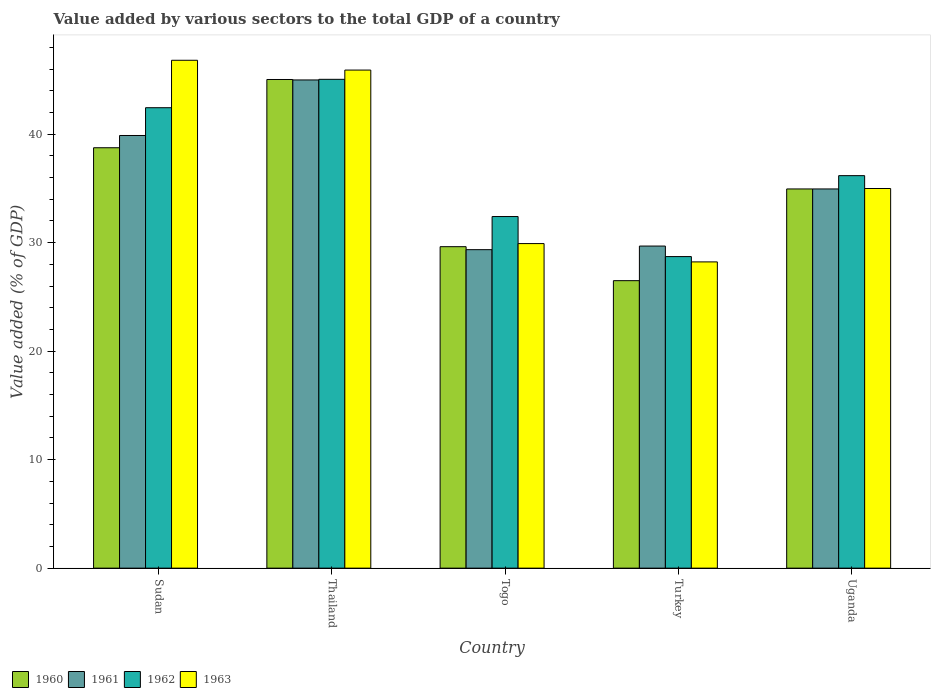How many different coloured bars are there?
Provide a succinct answer. 4. How many groups of bars are there?
Give a very brief answer. 5. Are the number of bars per tick equal to the number of legend labels?
Your answer should be compact. Yes. What is the label of the 2nd group of bars from the left?
Your response must be concise. Thailand. What is the value added by various sectors to the total GDP in 1961 in Togo?
Your answer should be compact. 29.35. Across all countries, what is the maximum value added by various sectors to the total GDP in 1960?
Ensure brevity in your answer.  45.04. Across all countries, what is the minimum value added by various sectors to the total GDP in 1962?
Your response must be concise. 28.72. In which country was the value added by various sectors to the total GDP in 1960 maximum?
Offer a terse response. Thailand. In which country was the value added by various sectors to the total GDP in 1962 minimum?
Make the answer very short. Turkey. What is the total value added by various sectors to the total GDP in 1961 in the graph?
Your response must be concise. 178.87. What is the difference between the value added by various sectors to the total GDP in 1963 in Sudan and that in Uganda?
Offer a very short reply. 11.82. What is the difference between the value added by various sectors to the total GDP in 1961 in Sudan and the value added by various sectors to the total GDP in 1960 in Turkey?
Your response must be concise. 13.38. What is the average value added by various sectors to the total GDP in 1962 per country?
Your response must be concise. 36.96. What is the difference between the value added by various sectors to the total GDP of/in 1962 and value added by various sectors to the total GDP of/in 1961 in Turkey?
Offer a terse response. -0.97. In how many countries, is the value added by various sectors to the total GDP in 1962 greater than 24 %?
Provide a succinct answer. 5. What is the ratio of the value added by various sectors to the total GDP in 1962 in Sudan to that in Thailand?
Provide a succinct answer. 0.94. What is the difference between the highest and the second highest value added by various sectors to the total GDP in 1961?
Your answer should be very brief. -10.05. What is the difference between the highest and the lowest value added by various sectors to the total GDP in 1963?
Provide a succinct answer. 18.58. Is the sum of the value added by various sectors to the total GDP in 1962 in Thailand and Uganda greater than the maximum value added by various sectors to the total GDP in 1961 across all countries?
Give a very brief answer. Yes. What does the 2nd bar from the left in Sudan represents?
Offer a very short reply. 1961. Is it the case that in every country, the sum of the value added by various sectors to the total GDP in 1960 and value added by various sectors to the total GDP in 1962 is greater than the value added by various sectors to the total GDP in 1961?
Keep it short and to the point. Yes. How many countries are there in the graph?
Your answer should be compact. 5. Are the values on the major ticks of Y-axis written in scientific E-notation?
Keep it short and to the point. No. How many legend labels are there?
Make the answer very short. 4. How are the legend labels stacked?
Provide a short and direct response. Horizontal. What is the title of the graph?
Make the answer very short. Value added by various sectors to the total GDP of a country. Does "2004" appear as one of the legend labels in the graph?
Your answer should be very brief. No. What is the label or title of the X-axis?
Offer a terse response. Country. What is the label or title of the Y-axis?
Provide a succinct answer. Value added (% of GDP). What is the Value added (% of GDP) of 1960 in Sudan?
Provide a short and direct response. 38.75. What is the Value added (% of GDP) in 1961 in Sudan?
Your answer should be compact. 39.88. What is the Value added (% of GDP) in 1962 in Sudan?
Keep it short and to the point. 42.44. What is the Value added (% of GDP) of 1963 in Sudan?
Your response must be concise. 46.81. What is the Value added (% of GDP) in 1960 in Thailand?
Provide a short and direct response. 45.04. What is the Value added (% of GDP) of 1961 in Thailand?
Keep it short and to the point. 45. What is the Value added (% of GDP) in 1962 in Thailand?
Your answer should be very brief. 45.05. What is the Value added (% of GDP) of 1963 in Thailand?
Make the answer very short. 45.91. What is the Value added (% of GDP) in 1960 in Togo?
Provide a short and direct response. 29.63. What is the Value added (% of GDP) of 1961 in Togo?
Give a very brief answer. 29.35. What is the Value added (% of GDP) of 1962 in Togo?
Offer a very short reply. 32.41. What is the Value added (% of GDP) of 1963 in Togo?
Provide a succinct answer. 29.91. What is the Value added (% of GDP) in 1960 in Turkey?
Provide a short and direct response. 26.5. What is the Value added (% of GDP) in 1961 in Turkey?
Provide a short and direct response. 29.69. What is the Value added (% of GDP) of 1962 in Turkey?
Your answer should be very brief. 28.72. What is the Value added (% of GDP) of 1963 in Turkey?
Provide a succinct answer. 28.23. What is the Value added (% of GDP) in 1960 in Uganda?
Give a very brief answer. 34.95. What is the Value added (% of GDP) of 1961 in Uganda?
Offer a terse response. 34.95. What is the Value added (% of GDP) of 1962 in Uganda?
Your response must be concise. 36.18. What is the Value added (% of GDP) in 1963 in Uganda?
Offer a terse response. 34.99. Across all countries, what is the maximum Value added (% of GDP) of 1960?
Your answer should be compact. 45.04. Across all countries, what is the maximum Value added (% of GDP) of 1961?
Your response must be concise. 45. Across all countries, what is the maximum Value added (% of GDP) of 1962?
Keep it short and to the point. 45.05. Across all countries, what is the maximum Value added (% of GDP) of 1963?
Offer a terse response. 46.81. Across all countries, what is the minimum Value added (% of GDP) in 1960?
Your response must be concise. 26.5. Across all countries, what is the minimum Value added (% of GDP) in 1961?
Provide a short and direct response. 29.35. Across all countries, what is the minimum Value added (% of GDP) in 1962?
Make the answer very short. 28.72. Across all countries, what is the minimum Value added (% of GDP) in 1963?
Offer a very short reply. 28.23. What is the total Value added (% of GDP) of 1960 in the graph?
Your answer should be very brief. 174.87. What is the total Value added (% of GDP) of 1961 in the graph?
Ensure brevity in your answer.  178.87. What is the total Value added (% of GDP) in 1962 in the graph?
Offer a terse response. 184.79. What is the total Value added (% of GDP) in 1963 in the graph?
Your response must be concise. 185.85. What is the difference between the Value added (% of GDP) of 1960 in Sudan and that in Thailand?
Provide a succinct answer. -6.29. What is the difference between the Value added (% of GDP) in 1961 in Sudan and that in Thailand?
Offer a very short reply. -5.12. What is the difference between the Value added (% of GDP) of 1962 in Sudan and that in Thailand?
Your answer should be compact. -2.62. What is the difference between the Value added (% of GDP) of 1963 in Sudan and that in Thailand?
Keep it short and to the point. 0.9. What is the difference between the Value added (% of GDP) in 1960 in Sudan and that in Togo?
Offer a terse response. 9.12. What is the difference between the Value added (% of GDP) of 1961 in Sudan and that in Togo?
Offer a very short reply. 10.52. What is the difference between the Value added (% of GDP) in 1962 in Sudan and that in Togo?
Offer a terse response. 10.03. What is the difference between the Value added (% of GDP) in 1963 in Sudan and that in Togo?
Keep it short and to the point. 16.9. What is the difference between the Value added (% of GDP) of 1960 in Sudan and that in Turkey?
Offer a terse response. 12.25. What is the difference between the Value added (% of GDP) in 1961 in Sudan and that in Turkey?
Offer a very short reply. 10.19. What is the difference between the Value added (% of GDP) of 1962 in Sudan and that in Turkey?
Your response must be concise. 13.72. What is the difference between the Value added (% of GDP) of 1963 in Sudan and that in Turkey?
Offer a terse response. 18.58. What is the difference between the Value added (% of GDP) of 1960 in Sudan and that in Uganda?
Ensure brevity in your answer.  3.8. What is the difference between the Value added (% of GDP) in 1961 in Sudan and that in Uganda?
Offer a terse response. 4.93. What is the difference between the Value added (% of GDP) in 1962 in Sudan and that in Uganda?
Your answer should be compact. 6.26. What is the difference between the Value added (% of GDP) in 1963 in Sudan and that in Uganda?
Provide a succinct answer. 11.82. What is the difference between the Value added (% of GDP) in 1960 in Thailand and that in Togo?
Give a very brief answer. 15.41. What is the difference between the Value added (% of GDP) in 1961 in Thailand and that in Togo?
Your response must be concise. 15.64. What is the difference between the Value added (% of GDP) in 1962 in Thailand and that in Togo?
Your answer should be compact. 12.65. What is the difference between the Value added (% of GDP) in 1963 in Thailand and that in Togo?
Give a very brief answer. 15.99. What is the difference between the Value added (% of GDP) in 1960 in Thailand and that in Turkey?
Provide a succinct answer. 18.54. What is the difference between the Value added (% of GDP) of 1961 in Thailand and that in Turkey?
Provide a succinct answer. 15.31. What is the difference between the Value added (% of GDP) in 1962 in Thailand and that in Turkey?
Offer a terse response. 16.34. What is the difference between the Value added (% of GDP) of 1963 in Thailand and that in Turkey?
Make the answer very short. 17.68. What is the difference between the Value added (% of GDP) of 1960 in Thailand and that in Uganda?
Ensure brevity in your answer.  10.09. What is the difference between the Value added (% of GDP) of 1961 in Thailand and that in Uganda?
Your response must be concise. 10.05. What is the difference between the Value added (% of GDP) in 1962 in Thailand and that in Uganda?
Your answer should be very brief. 8.88. What is the difference between the Value added (% of GDP) of 1963 in Thailand and that in Uganda?
Your response must be concise. 10.92. What is the difference between the Value added (% of GDP) of 1960 in Togo and that in Turkey?
Offer a very short reply. 3.13. What is the difference between the Value added (% of GDP) of 1961 in Togo and that in Turkey?
Your answer should be very brief. -0.33. What is the difference between the Value added (% of GDP) in 1962 in Togo and that in Turkey?
Your answer should be very brief. 3.69. What is the difference between the Value added (% of GDP) of 1963 in Togo and that in Turkey?
Your answer should be compact. 1.69. What is the difference between the Value added (% of GDP) in 1960 in Togo and that in Uganda?
Keep it short and to the point. -5.32. What is the difference between the Value added (% of GDP) in 1961 in Togo and that in Uganda?
Your response must be concise. -5.6. What is the difference between the Value added (% of GDP) in 1962 in Togo and that in Uganda?
Make the answer very short. -3.77. What is the difference between the Value added (% of GDP) in 1963 in Togo and that in Uganda?
Offer a terse response. -5.08. What is the difference between the Value added (% of GDP) in 1960 in Turkey and that in Uganda?
Make the answer very short. -8.45. What is the difference between the Value added (% of GDP) in 1961 in Turkey and that in Uganda?
Offer a very short reply. -5.26. What is the difference between the Value added (% of GDP) of 1962 in Turkey and that in Uganda?
Offer a terse response. -7.46. What is the difference between the Value added (% of GDP) of 1963 in Turkey and that in Uganda?
Provide a short and direct response. -6.76. What is the difference between the Value added (% of GDP) of 1960 in Sudan and the Value added (% of GDP) of 1961 in Thailand?
Your answer should be very brief. -6.25. What is the difference between the Value added (% of GDP) in 1960 in Sudan and the Value added (% of GDP) in 1962 in Thailand?
Give a very brief answer. -6.31. What is the difference between the Value added (% of GDP) in 1960 in Sudan and the Value added (% of GDP) in 1963 in Thailand?
Keep it short and to the point. -7.16. What is the difference between the Value added (% of GDP) in 1961 in Sudan and the Value added (% of GDP) in 1962 in Thailand?
Provide a short and direct response. -5.18. What is the difference between the Value added (% of GDP) in 1961 in Sudan and the Value added (% of GDP) in 1963 in Thailand?
Provide a short and direct response. -6.03. What is the difference between the Value added (% of GDP) in 1962 in Sudan and the Value added (% of GDP) in 1963 in Thailand?
Your answer should be very brief. -3.47. What is the difference between the Value added (% of GDP) in 1960 in Sudan and the Value added (% of GDP) in 1961 in Togo?
Offer a terse response. 9.39. What is the difference between the Value added (% of GDP) of 1960 in Sudan and the Value added (% of GDP) of 1962 in Togo?
Provide a succinct answer. 6.34. What is the difference between the Value added (% of GDP) of 1960 in Sudan and the Value added (% of GDP) of 1963 in Togo?
Provide a short and direct response. 8.83. What is the difference between the Value added (% of GDP) in 1961 in Sudan and the Value added (% of GDP) in 1962 in Togo?
Your answer should be compact. 7.47. What is the difference between the Value added (% of GDP) of 1961 in Sudan and the Value added (% of GDP) of 1963 in Togo?
Your response must be concise. 9.96. What is the difference between the Value added (% of GDP) of 1962 in Sudan and the Value added (% of GDP) of 1963 in Togo?
Your answer should be very brief. 12.52. What is the difference between the Value added (% of GDP) of 1960 in Sudan and the Value added (% of GDP) of 1961 in Turkey?
Provide a succinct answer. 9.06. What is the difference between the Value added (% of GDP) in 1960 in Sudan and the Value added (% of GDP) in 1962 in Turkey?
Provide a succinct answer. 10.03. What is the difference between the Value added (% of GDP) of 1960 in Sudan and the Value added (% of GDP) of 1963 in Turkey?
Offer a terse response. 10.52. What is the difference between the Value added (% of GDP) in 1961 in Sudan and the Value added (% of GDP) in 1962 in Turkey?
Offer a very short reply. 11.16. What is the difference between the Value added (% of GDP) of 1961 in Sudan and the Value added (% of GDP) of 1963 in Turkey?
Your response must be concise. 11.65. What is the difference between the Value added (% of GDP) in 1962 in Sudan and the Value added (% of GDP) in 1963 in Turkey?
Offer a very short reply. 14.21. What is the difference between the Value added (% of GDP) in 1960 in Sudan and the Value added (% of GDP) in 1961 in Uganda?
Give a very brief answer. 3.8. What is the difference between the Value added (% of GDP) in 1960 in Sudan and the Value added (% of GDP) in 1962 in Uganda?
Offer a very short reply. 2.57. What is the difference between the Value added (% of GDP) in 1960 in Sudan and the Value added (% of GDP) in 1963 in Uganda?
Provide a short and direct response. 3.76. What is the difference between the Value added (% of GDP) in 1961 in Sudan and the Value added (% of GDP) in 1962 in Uganda?
Offer a very short reply. 3.7. What is the difference between the Value added (% of GDP) of 1961 in Sudan and the Value added (% of GDP) of 1963 in Uganda?
Give a very brief answer. 4.89. What is the difference between the Value added (% of GDP) of 1962 in Sudan and the Value added (% of GDP) of 1963 in Uganda?
Offer a very short reply. 7.45. What is the difference between the Value added (% of GDP) in 1960 in Thailand and the Value added (% of GDP) in 1961 in Togo?
Give a very brief answer. 15.68. What is the difference between the Value added (% of GDP) in 1960 in Thailand and the Value added (% of GDP) in 1962 in Togo?
Keep it short and to the point. 12.63. What is the difference between the Value added (% of GDP) of 1960 in Thailand and the Value added (% of GDP) of 1963 in Togo?
Give a very brief answer. 15.12. What is the difference between the Value added (% of GDP) of 1961 in Thailand and the Value added (% of GDP) of 1962 in Togo?
Offer a terse response. 12.59. What is the difference between the Value added (% of GDP) of 1961 in Thailand and the Value added (% of GDP) of 1963 in Togo?
Your answer should be very brief. 15.08. What is the difference between the Value added (% of GDP) in 1962 in Thailand and the Value added (% of GDP) in 1963 in Togo?
Ensure brevity in your answer.  15.14. What is the difference between the Value added (% of GDP) of 1960 in Thailand and the Value added (% of GDP) of 1961 in Turkey?
Provide a succinct answer. 15.35. What is the difference between the Value added (% of GDP) in 1960 in Thailand and the Value added (% of GDP) in 1962 in Turkey?
Offer a very short reply. 16.32. What is the difference between the Value added (% of GDP) in 1960 in Thailand and the Value added (% of GDP) in 1963 in Turkey?
Offer a very short reply. 16.81. What is the difference between the Value added (% of GDP) of 1961 in Thailand and the Value added (% of GDP) of 1962 in Turkey?
Your response must be concise. 16.28. What is the difference between the Value added (% of GDP) in 1961 in Thailand and the Value added (% of GDP) in 1963 in Turkey?
Provide a succinct answer. 16.77. What is the difference between the Value added (% of GDP) of 1962 in Thailand and the Value added (% of GDP) of 1963 in Turkey?
Offer a very short reply. 16.83. What is the difference between the Value added (% of GDP) in 1960 in Thailand and the Value added (% of GDP) in 1961 in Uganda?
Offer a terse response. 10.09. What is the difference between the Value added (% of GDP) of 1960 in Thailand and the Value added (% of GDP) of 1962 in Uganda?
Provide a succinct answer. 8.86. What is the difference between the Value added (% of GDP) in 1960 in Thailand and the Value added (% of GDP) in 1963 in Uganda?
Ensure brevity in your answer.  10.05. What is the difference between the Value added (% of GDP) of 1961 in Thailand and the Value added (% of GDP) of 1962 in Uganda?
Ensure brevity in your answer.  8.82. What is the difference between the Value added (% of GDP) of 1961 in Thailand and the Value added (% of GDP) of 1963 in Uganda?
Make the answer very short. 10.01. What is the difference between the Value added (% of GDP) of 1962 in Thailand and the Value added (% of GDP) of 1963 in Uganda?
Your answer should be compact. 10.06. What is the difference between the Value added (% of GDP) of 1960 in Togo and the Value added (% of GDP) of 1961 in Turkey?
Offer a terse response. -0.06. What is the difference between the Value added (% of GDP) of 1960 in Togo and the Value added (% of GDP) of 1962 in Turkey?
Make the answer very short. 0.91. What is the difference between the Value added (% of GDP) of 1960 in Togo and the Value added (% of GDP) of 1963 in Turkey?
Keep it short and to the point. 1.4. What is the difference between the Value added (% of GDP) in 1961 in Togo and the Value added (% of GDP) in 1962 in Turkey?
Ensure brevity in your answer.  0.64. What is the difference between the Value added (% of GDP) in 1961 in Togo and the Value added (% of GDP) in 1963 in Turkey?
Your response must be concise. 1.13. What is the difference between the Value added (% of GDP) of 1962 in Togo and the Value added (% of GDP) of 1963 in Turkey?
Keep it short and to the point. 4.18. What is the difference between the Value added (% of GDP) of 1960 in Togo and the Value added (% of GDP) of 1961 in Uganda?
Give a very brief answer. -5.32. What is the difference between the Value added (% of GDP) of 1960 in Togo and the Value added (% of GDP) of 1962 in Uganda?
Your answer should be very brief. -6.55. What is the difference between the Value added (% of GDP) of 1960 in Togo and the Value added (% of GDP) of 1963 in Uganda?
Give a very brief answer. -5.36. What is the difference between the Value added (% of GDP) of 1961 in Togo and the Value added (% of GDP) of 1962 in Uganda?
Provide a succinct answer. -6.82. What is the difference between the Value added (% of GDP) of 1961 in Togo and the Value added (% of GDP) of 1963 in Uganda?
Your answer should be very brief. -5.64. What is the difference between the Value added (% of GDP) in 1962 in Togo and the Value added (% of GDP) in 1963 in Uganda?
Ensure brevity in your answer.  -2.58. What is the difference between the Value added (% of GDP) of 1960 in Turkey and the Value added (% of GDP) of 1961 in Uganda?
Your answer should be very brief. -8.45. What is the difference between the Value added (% of GDP) in 1960 in Turkey and the Value added (% of GDP) in 1962 in Uganda?
Your answer should be very brief. -9.68. What is the difference between the Value added (% of GDP) in 1960 in Turkey and the Value added (% of GDP) in 1963 in Uganda?
Your answer should be very brief. -8.49. What is the difference between the Value added (% of GDP) of 1961 in Turkey and the Value added (% of GDP) of 1962 in Uganda?
Give a very brief answer. -6.49. What is the difference between the Value added (% of GDP) of 1961 in Turkey and the Value added (% of GDP) of 1963 in Uganda?
Your response must be concise. -5.3. What is the difference between the Value added (% of GDP) of 1962 in Turkey and the Value added (% of GDP) of 1963 in Uganda?
Make the answer very short. -6.28. What is the average Value added (% of GDP) in 1960 per country?
Your response must be concise. 34.97. What is the average Value added (% of GDP) in 1961 per country?
Your response must be concise. 35.77. What is the average Value added (% of GDP) of 1962 per country?
Keep it short and to the point. 36.96. What is the average Value added (% of GDP) in 1963 per country?
Your answer should be compact. 37.17. What is the difference between the Value added (% of GDP) in 1960 and Value added (% of GDP) in 1961 in Sudan?
Ensure brevity in your answer.  -1.13. What is the difference between the Value added (% of GDP) in 1960 and Value added (% of GDP) in 1962 in Sudan?
Your answer should be compact. -3.69. What is the difference between the Value added (% of GDP) of 1960 and Value added (% of GDP) of 1963 in Sudan?
Keep it short and to the point. -8.06. What is the difference between the Value added (% of GDP) in 1961 and Value added (% of GDP) in 1962 in Sudan?
Provide a short and direct response. -2.56. What is the difference between the Value added (% of GDP) of 1961 and Value added (% of GDP) of 1963 in Sudan?
Ensure brevity in your answer.  -6.93. What is the difference between the Value added (% of GDP) of 1962 and Value added (% of GDP) of 1963 in Sudan?
Keep it short and to the point. -4.37. What is the difference between the Value added (% of GDP) of 1960 and Value added (% of GDP) of 1961 in Thailand?
Give a very brief answer. 0.04. What is the difference between the Value added (% of GDP) in 1960 and Value added (% of GDP) in 1962 in Thailand?
Provide a succinct answer. -0.02. What is the difference between the Value added (% of GDP) of 1960 and Value added (% of GDP) of 1963 in Thailand?
Your answer should be compact. -0.87. What is the difference between the Value added (% of GDP) in 1961 and Value added (% of GDP) in 1962 in Thailand?
Offer a very short reply. -0.06. What is the difference between the Value added (% of GDP) in 1961 and Value added (% of GDP) in 1963 in Thailand?
Offer a terse response. -0.91. What is the difference between the Value added (% of GDP) of 1962 and Value added (% of GDP) of 1963 in Thailand?
Provide a succinct answer. -0.85. What is the difference between the Value added (% of GDP) of 1960 and Value added (% of GDP) of 1961 in Togo?
Offer a terse response. 0.27. What is the difference between the Value added (% of GDP) in 1960 and Value added (% of GDP) in 1962 in Togo?
Provide a succinct answer. -2.78. What is the difference between the Value added (% of GDP) of 1960 and Value added (% of GDP) of 1963 in Togo?
Your answer should be compact. -0.28. What is the difference between the Value added (% of GDP) in 1961 and Value added (% of GDP) in 1962 in Togo?
Your answer should be compact. -3.05. What is the difference between the Value added (% of GDP) in 1961 and Value added (% of GDP) in 1963 in Togo?
Provide a short and direct response. -0.56. What is the difference between the Value added (% of GDP) in 1962 and Value added (% of GDP) in 1963 in Togo?
Provide a short and direct response. 2.49. What is the difference between the Value added (% of GDP) of 1960 and Value added (% of GDP) of 1961 in Turkey?
Your answer should be very brief. -3.19. What is the difference between the Value added (% of GDP) in 1960 and Value added (% of GDP) in 1962 in Turkey?
Ensure brevity in your answer.  -2.22. What is the difference between the Value added (% of GDP) of 1960 and Value added (% of GDP) of 1963 in Turkey?
Offer a very short reply. -1.73. What is the difference between the Value added (% of GDP) of 1961 and Value added (% of GDP) of 1962 in Turkey?
Offer a very short reply. 0.97. What is the difference between the Value added (% of GDP) of 1961 and Value added (% of GDP) of 1963 in Turkey?
Offer a very short reply. 1.46. What is the difference between the Value added (% of GDP) in 1962 and Value added (% of GDP) in 1963 in Turkey?
Give a very brief answer. 0.49. What is the difference between the Value added (% of GDP) in 1960 and Value added (% of GDP) in 1961 in Uganda?
Offer a very short reply. -0. What is the difference between the Value added (% of GDP) in 1960 and Value added (% of GDP) in 1962 in Uganda?
Provide a short and direct response. -1.23. What is the difference between the Value added (% of GDP) in 1960 and Value added (% of GDP) in 1963 in Uganda?
Provide a succinct answer. -0.04. What is the difference between the Value added (% of GDP) in 1961 and Value added (% of GDP) in 1962 in Uganda?
Keep it short and to the point. -1.23. What is the difference between the Value added (% of GDP) of 1961 and Value added (% of GDP) of 1963 in Uganda?
Give a very brief answer. -0.04. What is the difference between the Value added (% of GDP) in 1962 and Value added (% of GDP) in 1963 in Uganda?
Your answer should be very brief. 1.18. What is the ratio of the Value added (% of GDP) of 1960 in Sudan to that in Thailand?
Provide a succinct answer. 0.86. What is the ratio of the Value added (% of GDP) of 1961 in Sudan to that in Thailand?
Your answer should be very brief. 0.89. What is the ratio of the Value added (% of GDP) in 1962 in Sudan to that in Thailand?
Ensure brevity in your answer.  0.94. What is the ratio of the Value added (% of GDP) in 1963 in Sudan to that in Thailand?
Keep it short and to the point. 1.02. What is the ratio of the Value added (% of GDP) of 1960 in Sudan to that in Togo?
Make the answer very short. 1.31. What is the ratio of the Value added (% of GDP) in 1961 in Sudan to that in Togo?
Your answer should be very brief. 1.36. What is the ratio of the Value added (% of GDP) in 1962 in Sudan to that in Togo?
Offer a terse response. 1.31. What is the ratio of the Value added (% of GDP) of 1963 in Sudan to that in Togo?
Keep it short and to the point. 1.56. What is the ratio of the Value added (% of GDP) of 1960 in Sudan to that in Turkey?
Give a very brief answer. 1.46. What is the ratio of the Value added (% of GDP) in 1961 in Sudan to that in Turkey?
Your answer should be compact. 1.34. What is the ratio of the Value added (% of GDP) in 1962 in Sudan to that in Turkey?
Offer a very short reply. 1.48. What is the ratio of the Value added (% of GDP) of 1963 in Sudan to that in Turkey?
Provide a short and direct response. 1.66. What is the ratio of the Value added (% of GDP) of 1960 in Sudan to that in Uganda?
Offer a very short reply. 1.11. What is the ratio of the Value added (% of GDP) in 1961 in Sudan to that in Uganda?
Ensure brevity in your answer.  1.14. What is the ratio of the Value added (% of GDP) in 1962 in Sudan to that in Uganda?
Offer a very short reply. 1.17. What is the ratio of the Value added (% of GDP) of 1963 in Sudan to that in Uganda?
Provide a succinct answer. 1.34. What is the ratio of the Value added (% of GDP) of 1960 in Thailand to that in Togo?
Your response must be concise. 1.52. What is the ratio of the Value added (% of GDP) in 1961 in Thailand to that in Togo?
Ensure brevity in your answer.  1.53. What is the ratio of the Value added (% of GDP) in 1962 in Thailand to that in Togo?
Your answer should be very brief. 1.39. What is the ratio of the Value added (% of GDP) of 1963 in Thailand to that in Togo?
Provide a short and direct response. 1.53. What is the ratio of the Value added (% of GDP) of 1960 in Thailand to that in Turkey?
Offer a terse response. 1.7. What is the ratio of the Value added (% of GDP) of 1961 in Thailand to that in Turkey?
Provide a succinct answer. 1.52. What is the ratio of the Value added (% of GDP) in 1962 in Thailand to that in Turkey?
Provide a succinct answer. 1.57. What is the ratio of the Value added (% of GDP) in 1963 in Thailand to that in Turkey?
Provide a short and direct response. 1.63. What is the ratio of the Value added (% of GDP) of 1960 in Thailand to that in Uganda?
Your answer should be compact. 1.29. What is the ratio of the Value added (% of GDP) in 1961 in Thailand to that in Uganda?
Ensure brevity in your answer.  1.29. What is the ratio of the Value added (% of GDP) in 1962 in Thailand to that in Uganda?
Provide a succinct answer. 1.25. What is the ratio of the Value added (% of GDP) of 1963 in Thailand to that in Uganda?
Your response must be concise. 1.31. What is the ratio of the Value added (% of GDP) of 1960 in Togo to that in Turkey?
Give a very brief answer. 1.12. What is the ratio of the Value added (% of GDP) in 1962 in Togo to that in Turkey?
Ensure brevity in your answer.  1.13. What is the ratio of the Value added (% of GDP) in 1963 in Togo to that in Turkey?
Give a very brief answer. 1.06. What is the ratio of the Value added (% of GDP) in 1960 in Togo to that in Uganda?
Keep it short and to the point. 0.85. What is the ratio of the Value added (% of GDP) in 1961 in Togo to that in Uganda?
Offer a very short reply. 0.84. What is the ratio of the Value added (% of GDP) in 1962 in Togo to that in Uganda?
Make the answer very short. 0.9. What is the ratio of the Value added (% of GDP) of 1963 in Togo to that in Uganda?
Provide a short and direct response. 0.85. What is the ratio of the Value added (% of GDP) of 1960 in Turkey to that in Uganda?
Your answer should be compact. 0.76. What is the ratio of the Value added (% of GDP) in 1961 in Turkey to that in Uganda?
Your response must be concise. 0.85. What is the ratio of the Value added (% of GDP) of 1962 in Turkey to that in Uganda?
Ensure brevity in your answer.  0.79. What is the ratio of the Value added (% of GDP) in 1963 in Turkey to that in Uganda?
Give a very brief answer. 0.81. What is the difference between the highest and the second highest Value added (% of GDP) of 1960?
Your answer should be very brief. 6.29. What is the difference between the highest and the second highest Value added (% of GDP) in 1961?
Offer a terse response. 5.12. What is the difference between the highest and the second highest Value added (% of GDP) in 1962?
Your response must be concise. 2.62. What is the difference between the highest and the second highest Value added (% of GDP) in 1963?
Offer a very short reply. 0.9. What is the difference between the highest and the lowest Value added (% of GDP) in 1960?
Make the answer very short. 18.54. What is the difference between the highest and the lowest Value added (% of GDP) in 1961?
Keep it short and to the point. 15.64. What is the difference between the highest and the lowest Value added (% of GDP) of 1962?
Your response must be concise. 16.34. What is the difference between the highest and the lowest Value added (% of GDP) in 1963?
Offer a very short reply. 18.58. 